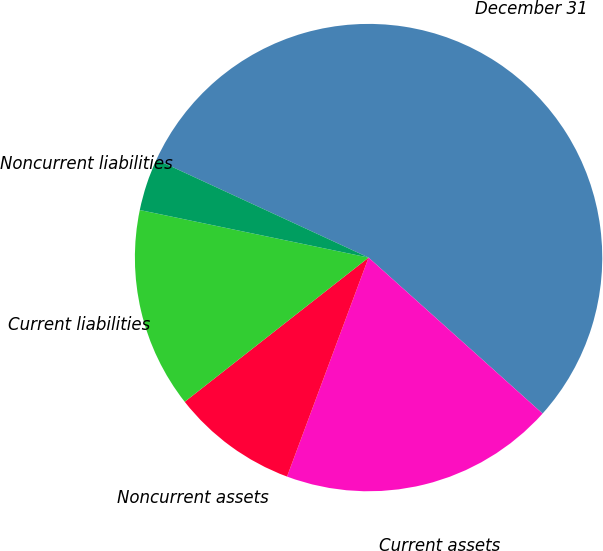Convert chart. <chart><loc_0><loc_0><loc_500><loc_500><pie_chart><fcel>December 31<fcel>Current assets<fcel>Noncurrent assets<fcel>Current liabilities<fcel>Noncurrent liabilities<nl><fcel>54.75%<fcel>19.04%<fcel>8.74%<fcel>13.85%<fcel>3.62%<nl></chart> 